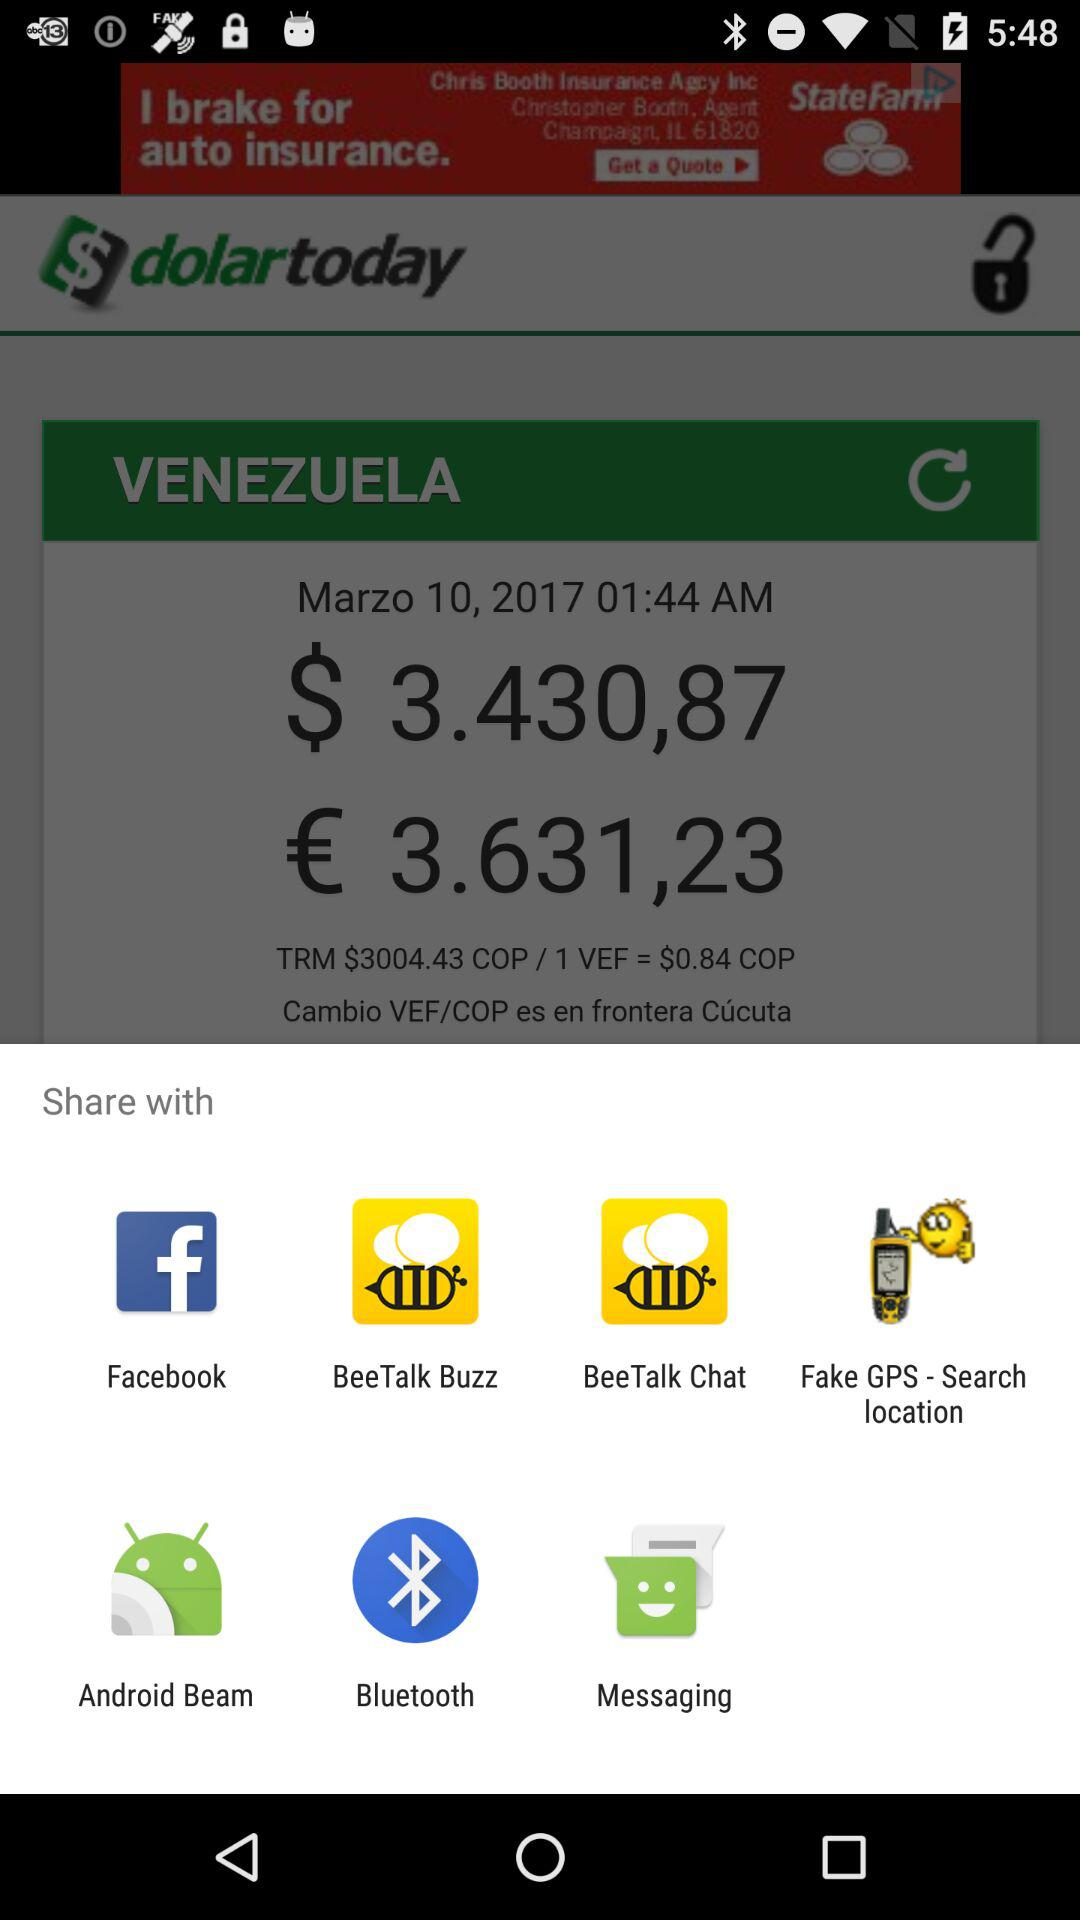Through what app can I share? We can share with "Facebook", "BeeTalk Buzz", "BeeTalk Chart", "Fake GPS - Search location", "Android Beam", "Bluetooth", and "Messaging". 